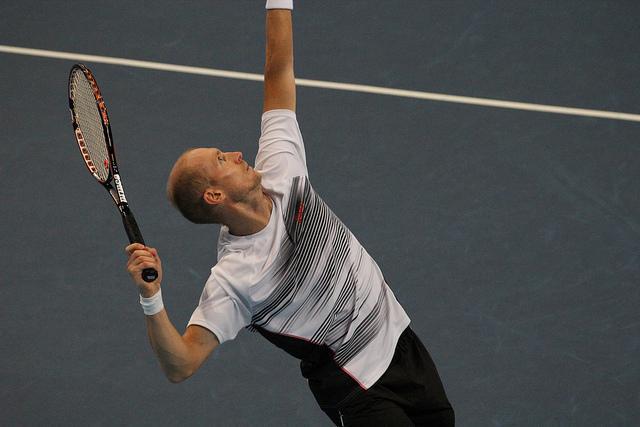How many zebras are behind the giraffes?
Give a very brief answer. 0. 